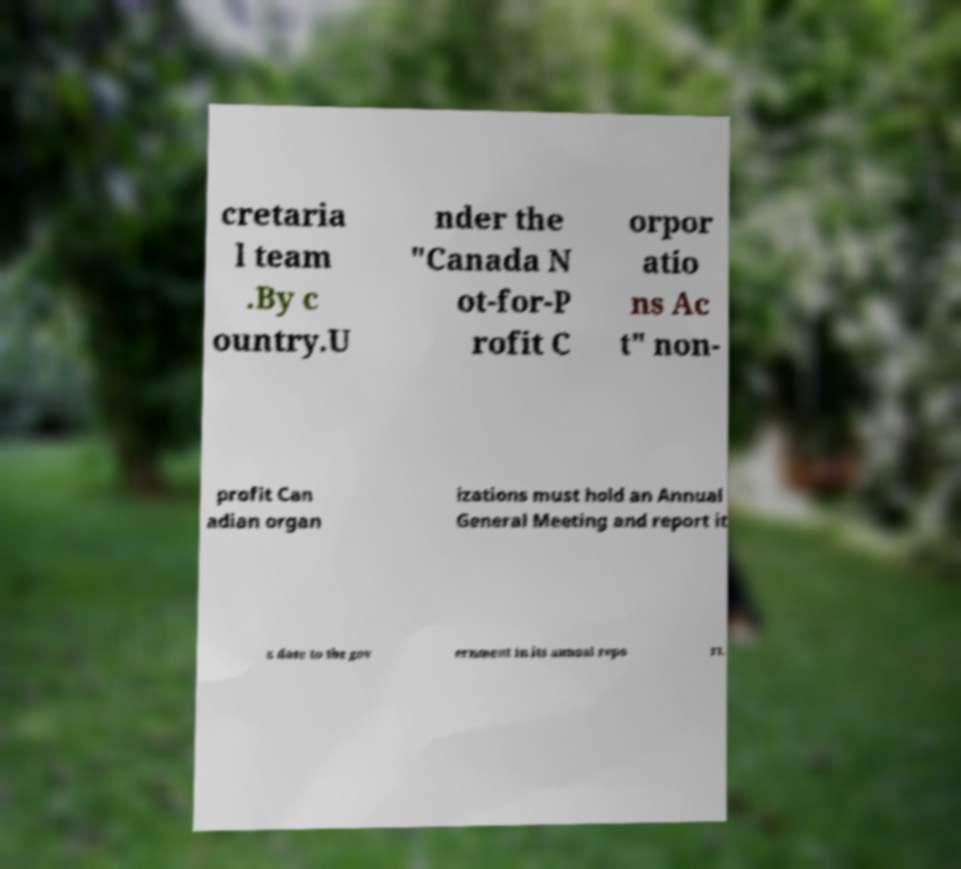Can you accurately transcribe the text from the provided image for me? cretaria l team .By c ountry.U nder the "Canada N ot-for-P rofit C orpor atio ns Ac t" non- profit Can adian organ izations must hold an Annual General Meeting and report it s date to the gov ernment in its annual repo rt. 